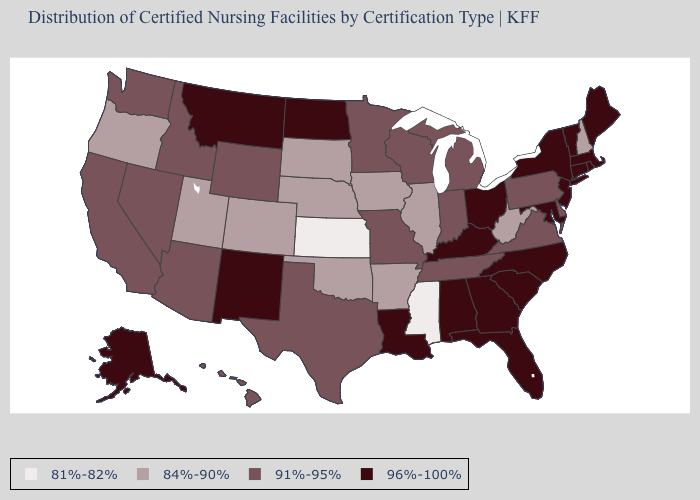What is the value of Missouri?
Give a very brief answer. 91%-95%. Among the states that border Wyoming , which have the lowest value?
Quick response, please. Colorado, Nebraska, South Dakota, Utah. What is the highest value in the USA?
Keep it brief. 96%-100%. What is the value of Oregon?
Give a very brief answer. 84%-90%. Is the legend a continuous bar?
Be succinct. No. Does Michigan have a higher value than Tennessee?
Short answer required. No. What is the value of Wyoming?
Answer briefly. 91%-95%. What is the value of Utah?
Write a very short answer. 84%-90%. Among the states that border Montana , which have the lowest value?
Answer briefly. South Dakota. Which states hav the highest value in the South?
Keep it brief. Alabama, Florida, Georgia, Kentucky, Louisiana, Maryland, North Carolina, South Carolina. Name the states that have a value in the range 81%-82%?
Be succinct. Kansas, Mississippi. Name the states that have a value in the range 84%-90%?
Quick response, please. Arkansas, Colorado, Illinois, Iowa, Nebraska, New Hampshire, Oklahoma, Oregon, South Dakota, Utah, West Virginia. Name the states that have a value in the range 81%-82%?
Be succinct. Kansas, Mississippi. Name the states that have a value in the range 81%-82%?
Concise answer only. Kansas, Mississippi. Does New Hampshire have the highest value in the Northeast?
Give a very brief answer. No. 